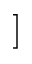Convert formula to latex. <formula><loc_0><loc_0><loc_500><loc_500>]</formula> 